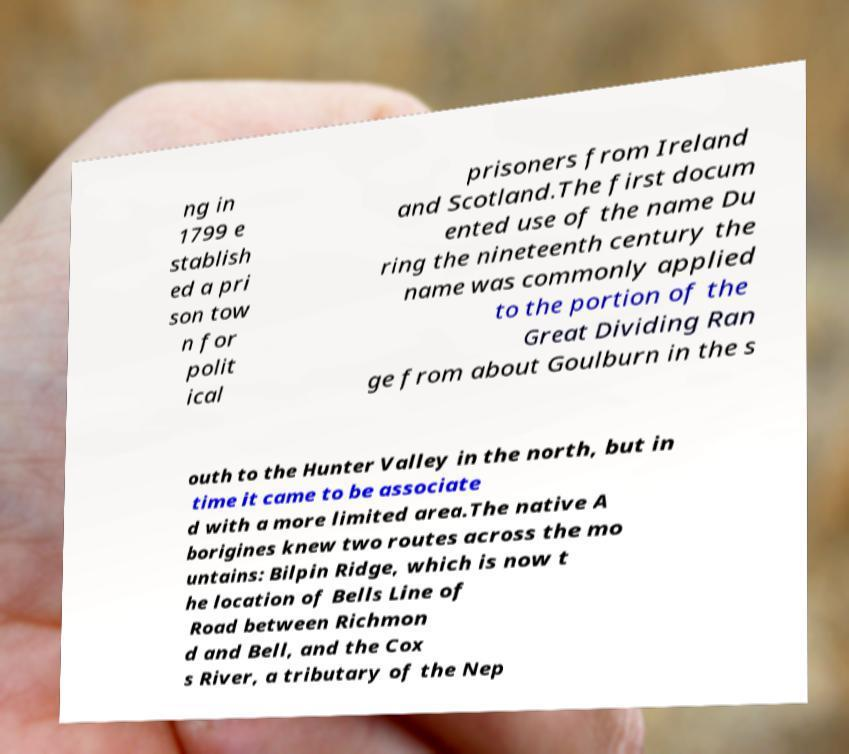For documentation purposes, I need the text within this image transcribed. Could you provide that? ng in 1799 e stablish ed a pri son tow n for polit ical prisoners from Ireland and Scotland.The first docum ented use of the name Du ring the nineteenth century the name was commonly applied to the portion of the Great Dividing Ran ge from about Goulburn in the s outh to the Hunter Valley in the north, but in time it came to be associate d with a more limited area.The native A borigines knew two routes across the mo untains: Bilpin Ridge, which is now t he location of Bells Line of Road between Richmon d and Bell, and the Cox s River, a tributary of the Nep 